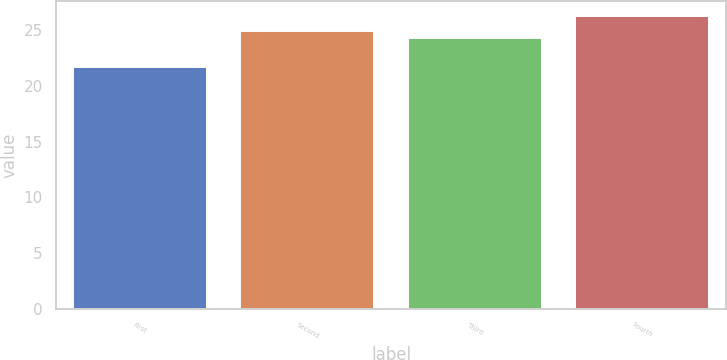Convert chart to OTSL. <chart><loc_0><loc_0><loc_500><loc_500><bar_chart><fcel>First<fcel>Second<fcel>Third<fcel>Fourth<nl><fcel>21.72<fcel>24.9<fcel>24.32<fcel>26.29<nl></chart> 